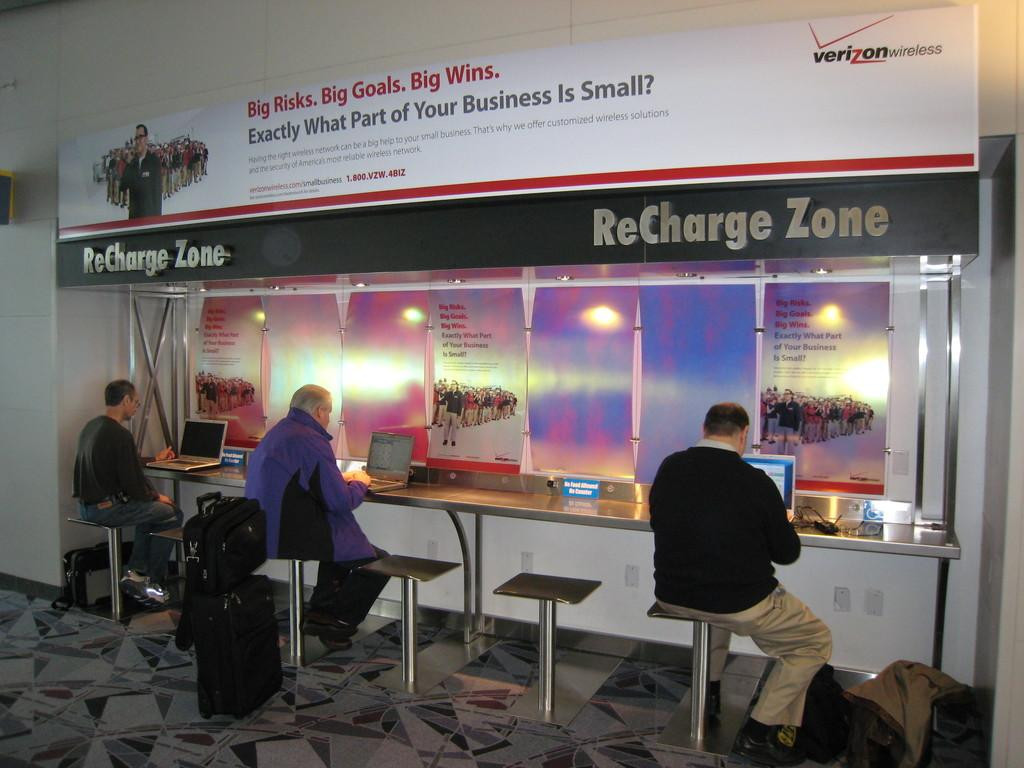<image>
Present a compact description of the photo's key features. People sit at a ReCharge Zone in front of mobile devices. 